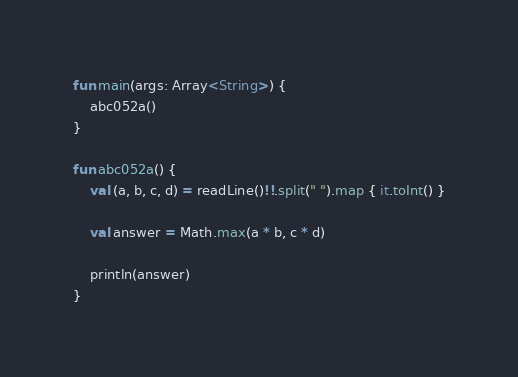Convert code to text. <code><loc_0><loc_0><loc_500><loc_500><_Kotlin_>fun main(args: Array<String>) {
    abc052a()
}

fun abc052a() {
    val (a, b, c, d) = readLine()!!.split(" ").map { it.toInt() }

    val answer = Math.max(a * b, c * d)

    println(answer)
}
</code> 